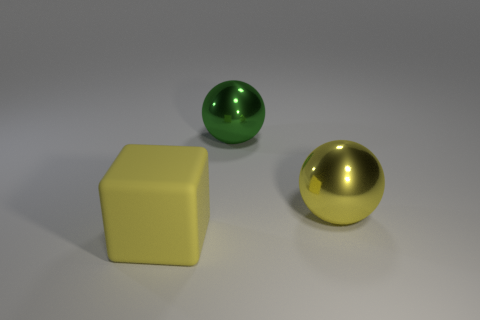There is a thing that is the same material as the big green sphere; what color is it?
Ensure brevity in your answer.  Yellow. How many large objects are spheres or cyan metal cubes?
Provide a short and direct response. 2. How many big spheres are to the right of the yellow rubber thing?
Ensure brevity in your answer.  2. There is another large shiny object that is the same shape as the large yellow shiny thing; what is its color?
Make the answer very short. Green. How many rubber objects are balls or large blocks?
Ensure brevity in your answer.  1. Are there any metal objects in front of the big object in front of the yellow thing to the right of the cube?
Your response must be concise. No. The matte cube has what color?
Your response must be concise. Yellow. There is a big yellow object that is on the right side of the big matte block; is its shape the same as the rubber thing?
Make the answer very short. No. How many objects are either large gray rubber balls or yellow objects to the right of the yellow rubber object?
Your response must be concise. 1. Does the big yellow block in front of the green object have the same material as the big green sphere?
Your answer should be very brief. No. 